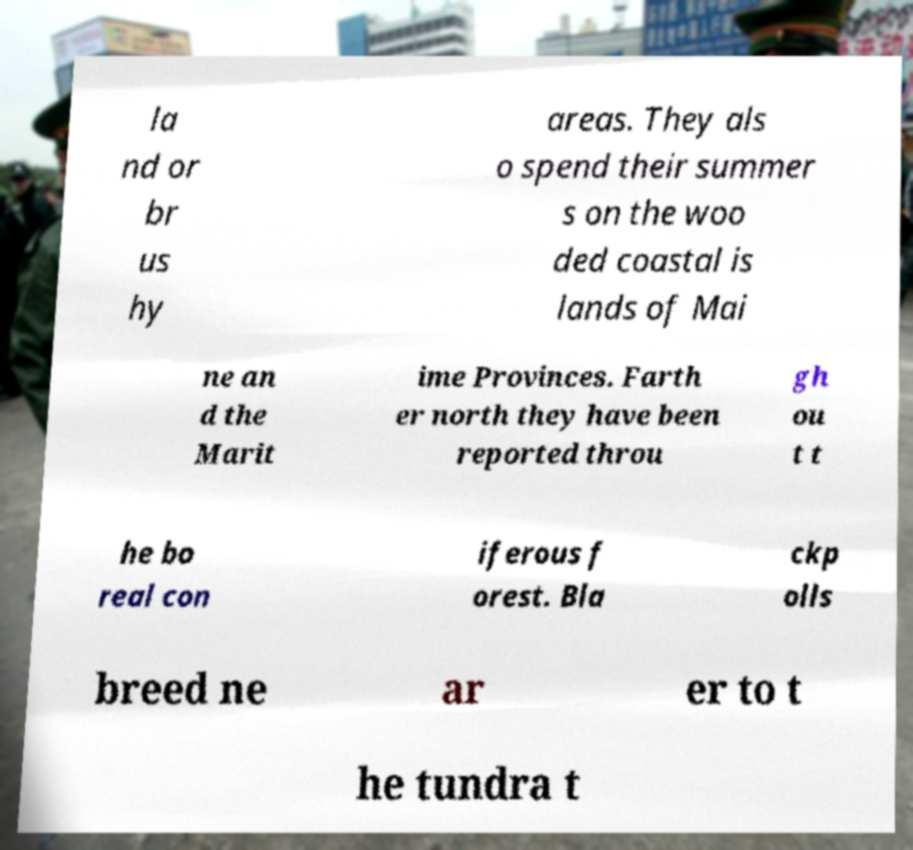Could you extract and type out the text from this image? la nd or br us hy areas. They als o spend their summer s on the woo ded coastal is lands of Mai ne an d the Marit ime Provinces. Farth er north they have been reported throu gh ou t t he bo real con iferous f orest. Bla ckp olls breed ne ar er to t he tundra t 